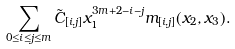Convert formula to latex. <formula><loc_0><loc_0><loc_500><loc_500>\sum _ { 0 \leq i \leq j \leq m } \tilde { C } _ { [ i , j ] } x _ { 1 } ^ { 3 m + 2 - i - j } m _ { [ i , j ] } ( x _ { 2 } , x _ { 3 } ) .</formula> 